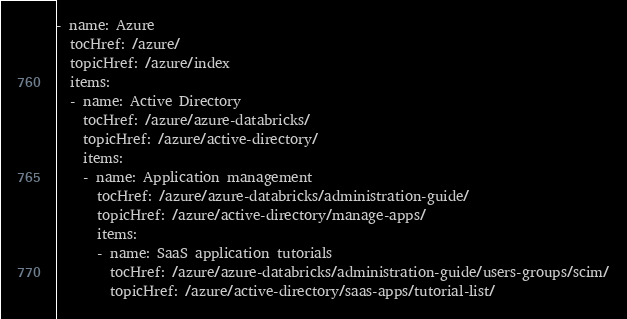<code> <loc_0><loc_0><loc_500><loc_500><_YAML_>- name: Azure
  tocHref: /azure/
  topicHref: /azure/index
  items:
  - name: Active Directory
    tocHref: /azure/azure-databricks/
    topicHref: /azure/active-directory/
    items: 
    - name: Application management
      tocHref: /azure/azure-databricks/administration-guide/
      topicHref: /azure/active-directory/manage-apps/
      items: 
      - name: SaaS application tutorials
        tocHref: /azure/azure-databricks/administration-guide/users-groups/scim/
        topicHref: /azure/active-directory/saas-apps/tutorial-list/</code> 